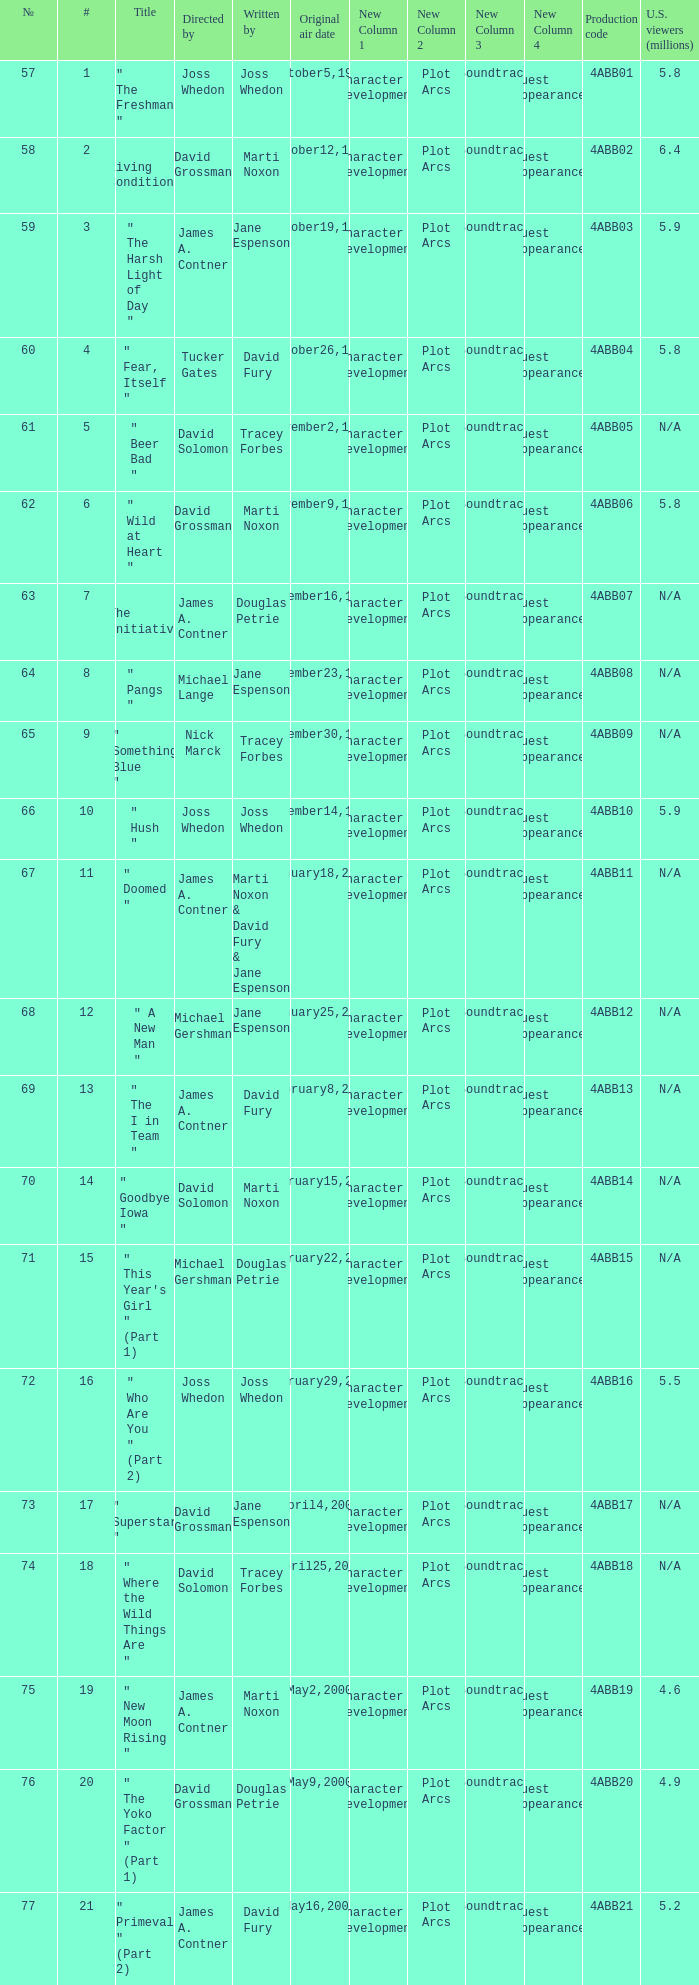What is the season 4 # for the production code of 4abb07? 7.0. 